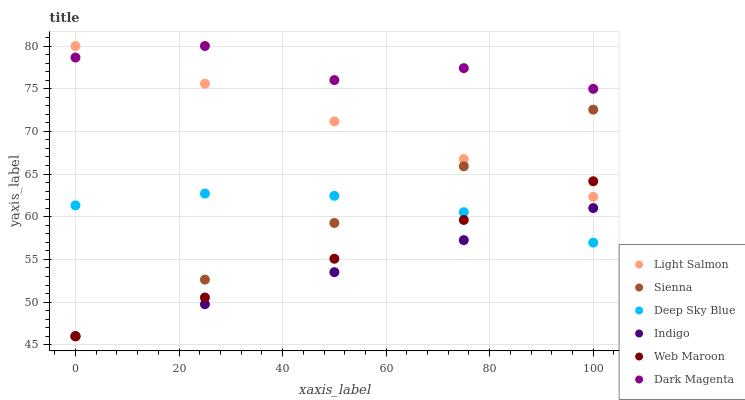Does Indigo have the minimum area under the curve?
Answer yes or no. Yes. Does Dark Magenta have the maximum area under the curve?
Answer yes or no. Yes. Does Dark Magenta have the minimum area under the curve?
Answer yes or no. No. Does Indigo have the maximum area under the curve?
Answer yes or no. No. Is Light Salmon the smoothest?
Answer yes or no. Yes. Is Dark Magenta the roughest?
Answer yes or no. Yes. Is Indigo the smoothest?
Answer yes or no. No. Is Indigo the roughest?
Answer yes or no. No. Does Indigo have the lowest value?
Answer yes or no. Yes. Does Dark Magenta have the lowest value?
Answer yes or no. No. Does Dark Magenta have the highest value?
Answer yes or no. Yes. Does Indigo have the highest value?
Answer yes or no. No. Is Deep Sky Blue less than Light Salmon?
Answer yes or no. Yes. Is Dark Magenta greater than Web Maroon?
Answer yes or no. Yes. Does Web Maroon intersect Sienna?
Answer yes or no. Yes. Is Web Maroon less than Sienna?
Answer yes or no. No. Is Web Maroon greater than Sienna?
Answer yes or no. No. Does Deep Sky Blue intersect Light Salmon?
Answer yes or no. No. 